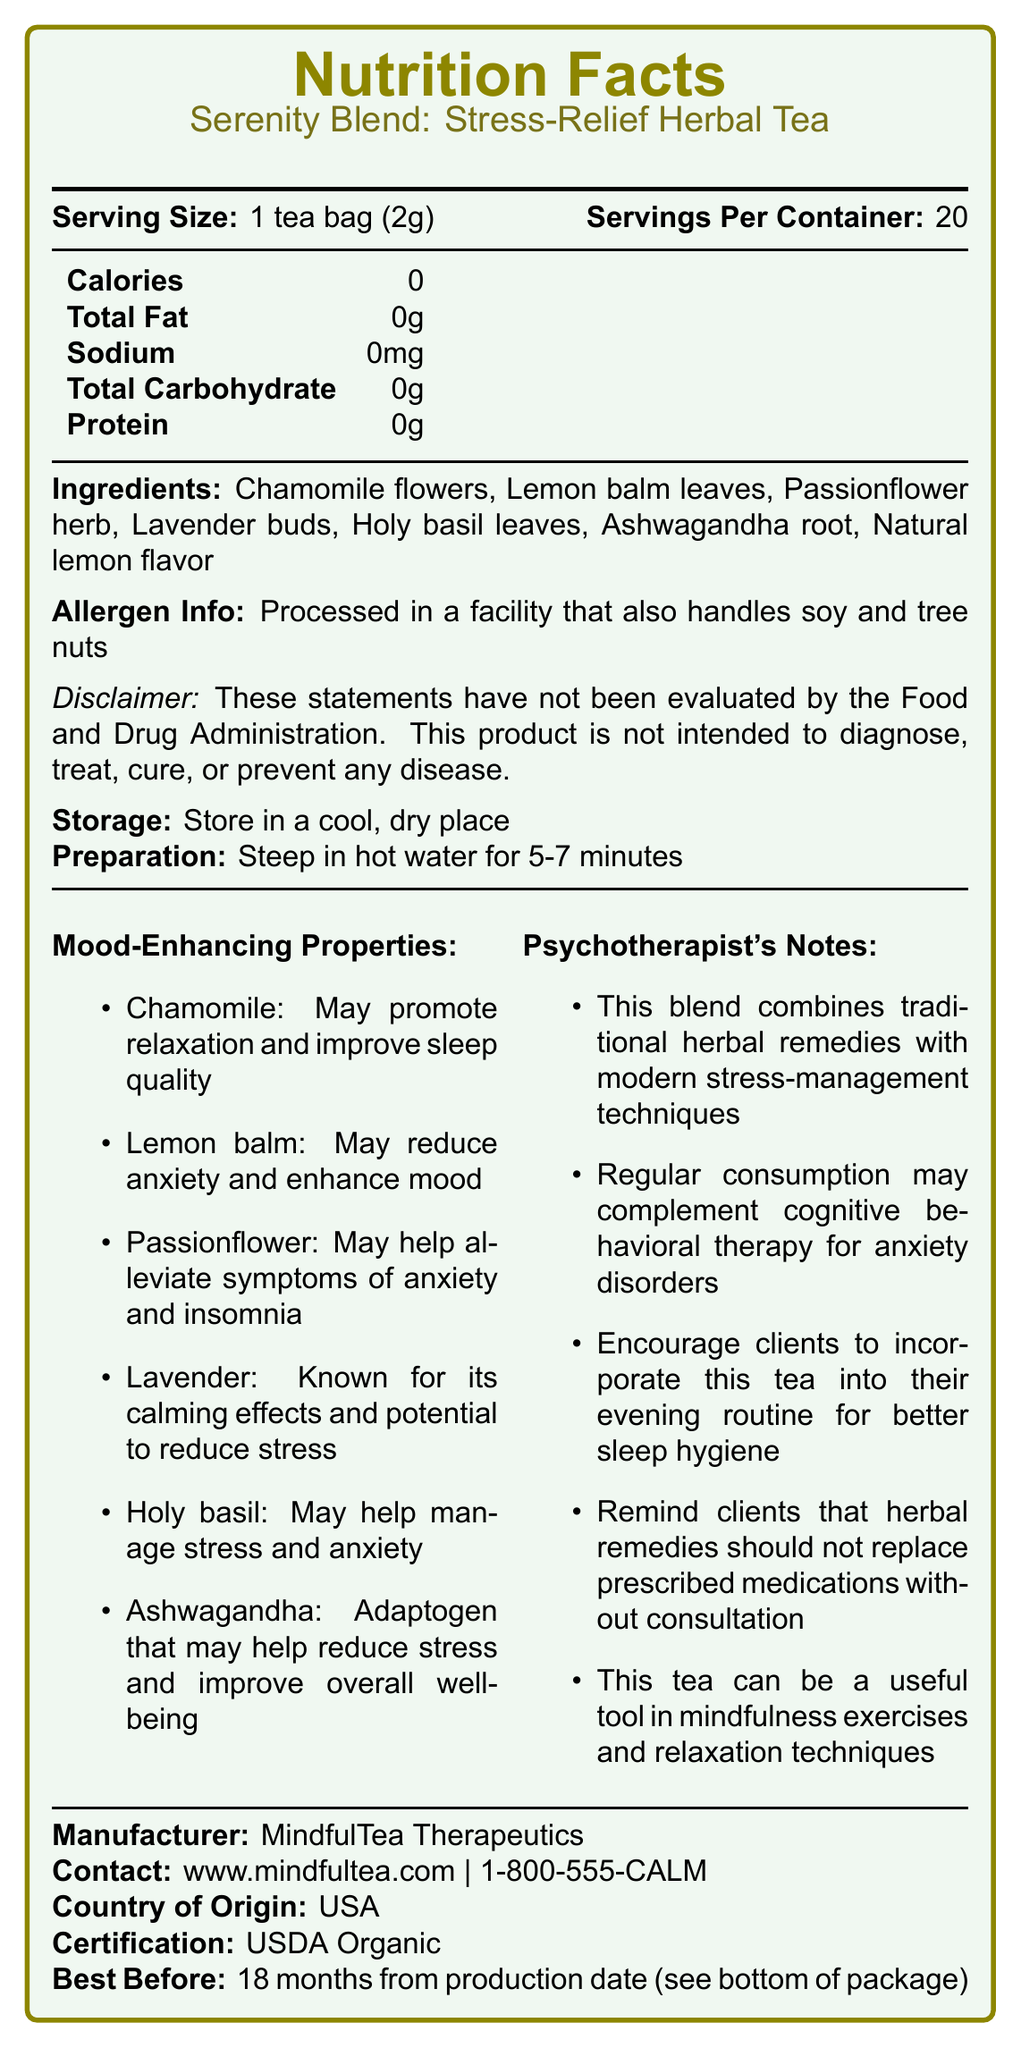What is the serving size of the Serenity Blend: Stress-Relief Herbal Tea? The serving size is mentioned right at the top of the Nutrition Facts section.
Answer: 1 tea bag (2g) How many servings are there per container? According to the Nutrition Facts section, there are 20 servings per container.
Answer: 20 What is the total calorie count per serving? The total calories per serving are listed as 0 in the Nutrition Facts section.
Answer: 0 List the ingredients in the Serenity Blend: Stress-Relief Herbal Tea. The ingredients are mentioned under the Ingredients section of the document.
Answer: Chamomile flowers, Lemon balm leaves, Passionflower herb, Lavender buds, Holy basil leaves, Ashwagandha root, Natural lemon flavor What allergen information is provided? The allergen information is given directly under the Ingredients section.
Answer: Processed in a facility that also handles soy and tree nuts Which of these ingredients is known for its potential to reduce stress? A. Chamomile B. Lemon balm C. Lavender According to the Mood-Enhancing Properties section, Lavender is known for its calming effects and potential to reduce stress.
Answer: C. Lavender What should you do to prepare the tea? The preparation instructions state to steep the tea in hot water for 5-7 minutes.
Answer: Steep in hot water for 5-7 minutes What storage instructions are provided for the tea? The storage instructions are specified as "Store in a cool, dry place."
Answer: Store in a cool, dry place Is Serenity Blend certified organic? The document states the certification as USDA Organic under the Manufacturer and Certification section.
Answer: Yes What is the purpose of consuming this herbal tea blend according to the document? The document mentions both Mood-Enhancing Properties and Psychotherapist's Notes detailing the stress-relief and mood-enhancing benefits.
Answer: To relieve stress and enhance mood Who manufactures the Serenity Blend: Stress-Relief Herbal Tea? The manufacturer is listed under the Manufacturer, Contact, and Country of Origin section.
Answer: MindfulTea Therapeutics Which ingredient is an adaptogen that may help reduce stress and improve overall well-being? According to the Mood-Enhancing Properties, Ashwagandha is mentioned as an adaptogen that may help reduce stress and improve overall well-being.
Answer: Ashwagandha True or False: The Serenity Blend has a significant amount of protein. According to the Nutrition Facts, the tea has 0g of protein.
Answer: False Why might a psychotherapist recommend this tea blend to clients? The Psychotherapist's Notes section provides various reasons why a psychotherapist might recommend this tea blend.
Answer: To complement cognitive behavioral therapy, improve sleep hygiene, and aid in mindfulness and relaxation techniques What is the best before date for this product? The best before date is provided as 18 months from the production date, as mentioned at the end of the document.
Answer: 18 months from production date (see bottom of package) Summarize the key points of the Serenity Blend: Stress-Relief Herbal Tea document. The document comprehensively outlines the nutritional information, allergen info, ingredients, storage and preparation instructions, mood-enhancing properties, and notes from a psychotherapist. Additionally, it includes manufacturer details and organic certification.
Answer: The Serenity Blend: Stress-Relief Herbal Tea is an organic herbal tea blend designed to alleviate stress and enhance mood. It has zero calories, fat, sodium, carbohydrates, and protein per serving. The blend includes ingredients like Chamomile, Lemon balm, Passionflower, Lavender, Holy basil, Ashwagandha, and Natural lemon flavor. It is processed in a facility that handles soy and tree nuts. The tea should be steeped for 5-7 minutes in hot water and stored in a cool, dry place. The document also provides mood-enhancing properties of the ingredients and psychotherapist’s notes on its benefits. Can a child consume this herbal tea blend without any considerations? The document does not address whether the tea is safe specifically for children, so further information or a consultation with a healthcare provider would be needed.
Answer: Not enough information 